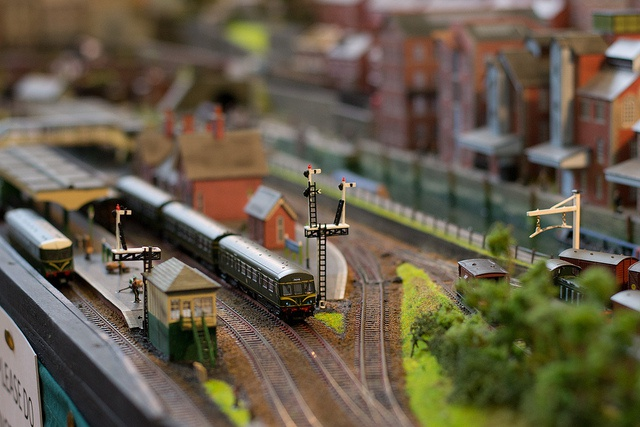Describe the objects in this image and their specific colors. I can see train in maroon, black, lightgray, gray, and darkgray tones, train in maroon, black, lightgray, gray, and darkgray tones, train in maroon, darkgray, gray, and black tones, and traffic light in maroon, black, and gray tones in this image. 